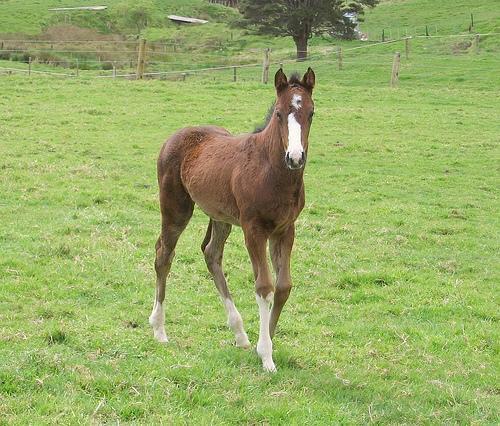How many giraffes are there?
Give a very brief answer. 0. 